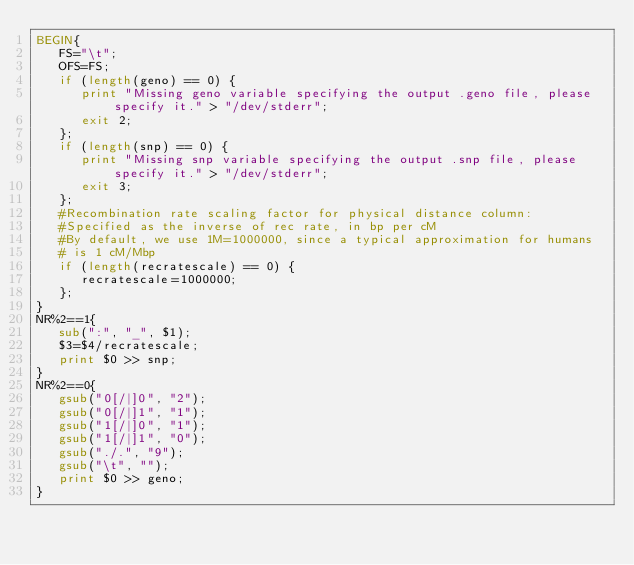<code> <loc_0><loc_0><loc_500><loc_500><_Awk_>BEGIN{
   FS="\t";
   OFS=FS;
   if (length(geno) == 0) {
      print "Missing geno variable specifying the output .geno file, please specify it." > "/dev/stderr";
      exit 2;
   };
   if (length(snp) == 0) {
      print "Missing snp variable specifying the output .snp file, please specify it." > "/dev/stderr";
      exit 3;
   };
   #Recombination rate scaling factor for physical distance column:
   #Specified as the inverse of rec rate, in bp per cM
   #By default, we use 1M=1000000, since a typical approximation for humans
   # is 1 cM/Mbp
   if (length(recratescale) == 0) {
      recratescale=1000000;
   };
}
NR%2==1{
   sub(":", "_", $1);
   $3=$4/recratescale;
   print $0 >> snp;
}
NR%2==0{
   gsub("0[/|]0", "2");
   gsub("0[/|]1", "1");
   gsub("1[/|]0", "1");
   gsub("1[/|]1", "0");
   gsub("./.", "9");
   gsub("\t", "");
   print $0 >> geno;
}
</code> 